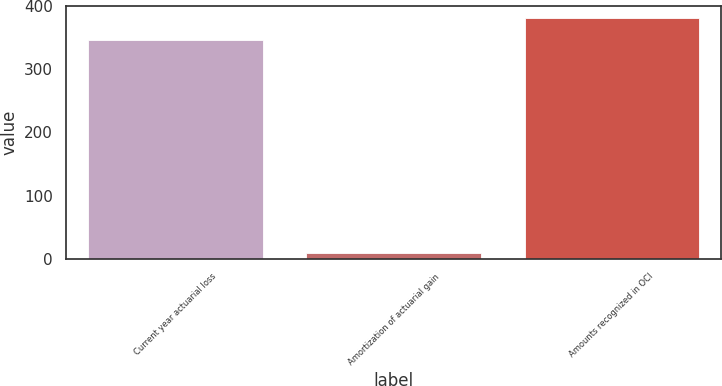Convert chart. <chart><loc_0><loc_0><loc_500><loc_500><bar_chart><fcel>Current year actuarial loss<fcel>Amortization of actuarial gain<fcel>Amounts recognized in OCI<nl><fcel>347<fcel>9<fcel>381.9<nl></chart> 